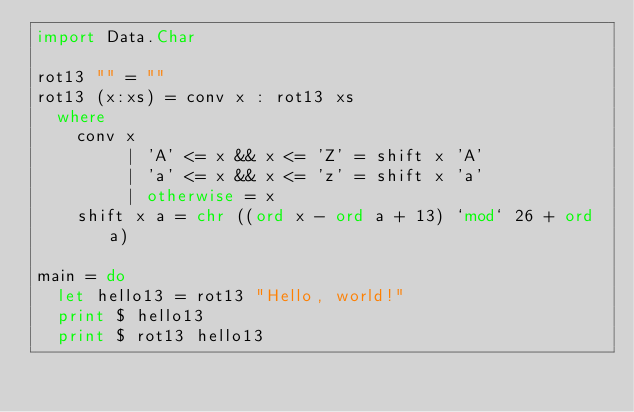<code> <loc_0><loc_0><loc_500><loc_500><_Haskell_>import Data.Char

rot13 "" = ""
rot13 (x:xs) = conv x : rot13 xs
  where
    conv x
         | 'A' <= x && x <= 'Z' = shift x 'A'
         | 'a' <= x && x <= 'z' = shift x 'a'
         | otherwise = x
    shift x a = chr ((ord x - ord a + 13) `mod` 26 + ord a)

main = do
  let hello13 = rot13 "Hello, world!"
  print $ hello13
  print $ rot13 hello13
</code> 